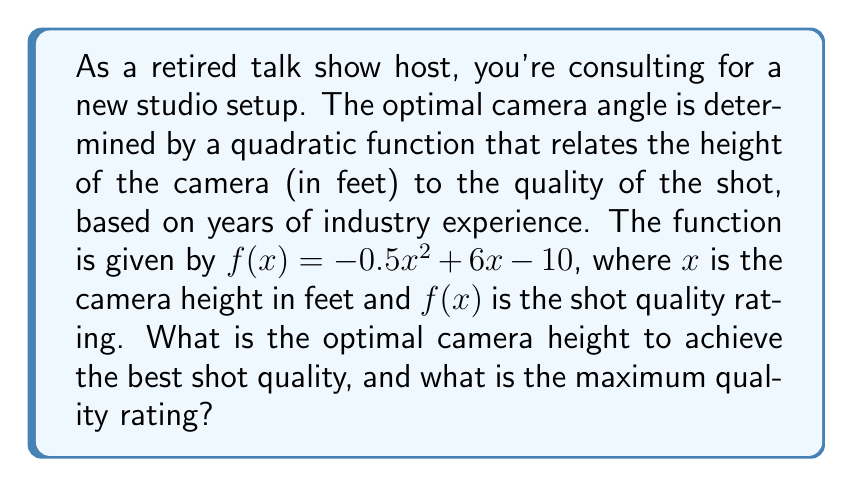Provide a solution to this math problem. To find the optimal camera height and the maximum quality rating, we need to find the vertex of the parabola represented by the quadratic function $f(x) = -0.5x^2 + 6x - 10$.

1) For a quadratic function in the form $f(x) = ax^2 + bx + c$, the x-coordinate of the vertex is given by $x = -\frac{b}{2a}$.

2) In this case, $a = -0.5$, $b = 6$, and $c = -10$.

3) Calculating the x-coordinate of the vertex:
   $$x = -\frac{6}{2(-0.5)} = -\frac{6}{-1} = 6$$

4) This means the optimal camera height is 6 feet.

5) To find the maximum quality rating, we substitute $x = 6$ into the original function:

   $$\begin{align}
   f(6) &= -0.5(6)^2 + 6(6) - 10 \\
        &= -0.5(36) + 36 - 10 \\
        &= -18 + 36 - 10 \\
        &= 8
   \end{align}$$

Therefore, the maximum quality rating is 8.

[asy]
import graph;
size(200,200);
real f(real x) {return -0.5x^2+6x-10;}
xaxis("x",Ticks());
yaxis("y",Ticks());
draw(graph(f,0,12));
dot((6,8));
label("(6,8)",(6,8),NE);
[/asy]
Answer: The optimal camera height is 6 feet, and the maximum quality rating is 8. 